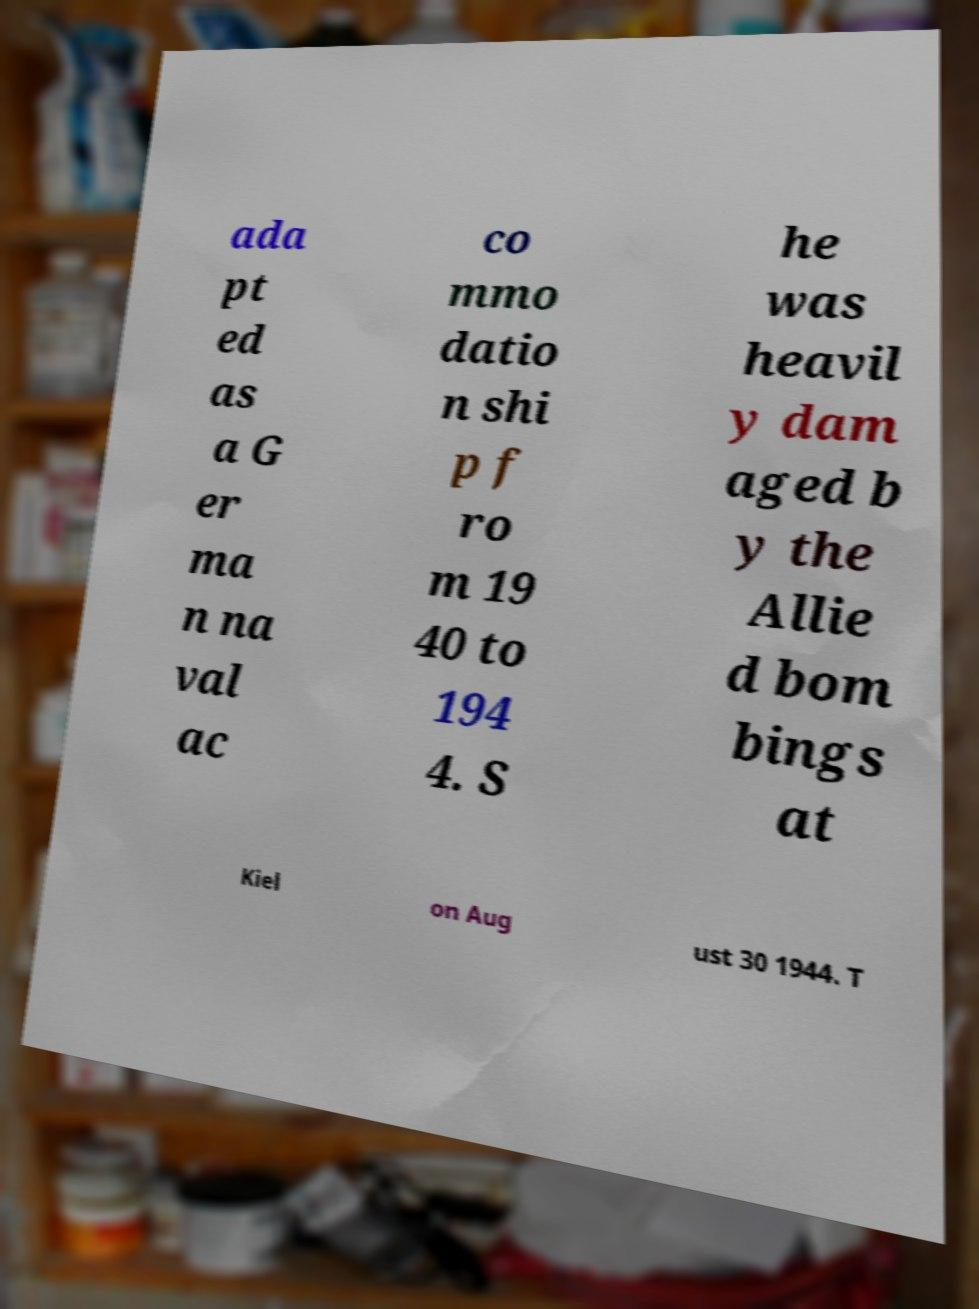What messages or text are displayed in this image? I need them in a readable, typed format. ada pt ed as a G er ma n na val ac co mmo datio n shi p f ro m 19 40 to 194 4. S he was heavil y dam aged b y the Allie d bom bings at Kiel on Aug ust 30 1944. T 